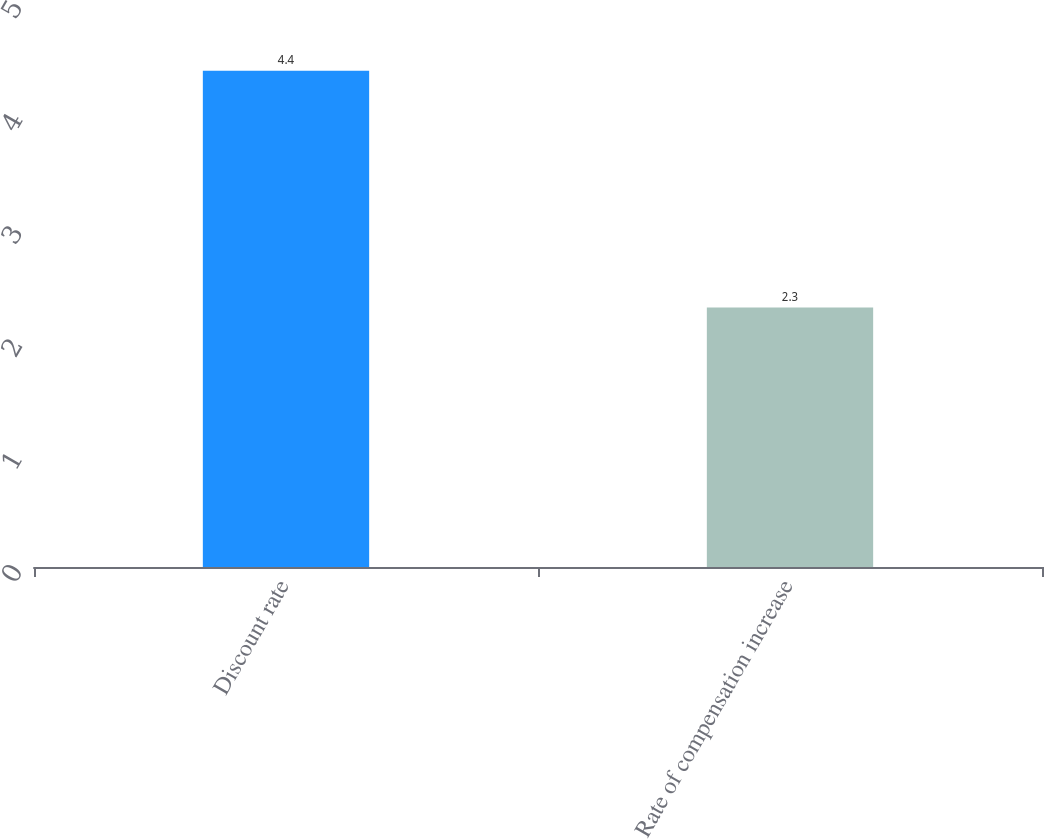Convert chart to OTSL. <chart><loc_0><loc_0><loc_500><loc_500><bar_chart><fcel>Discount rate<fcel>Rate of compensation increase<nl><fcel>4.4<fcel>2.3<nl></chart> 